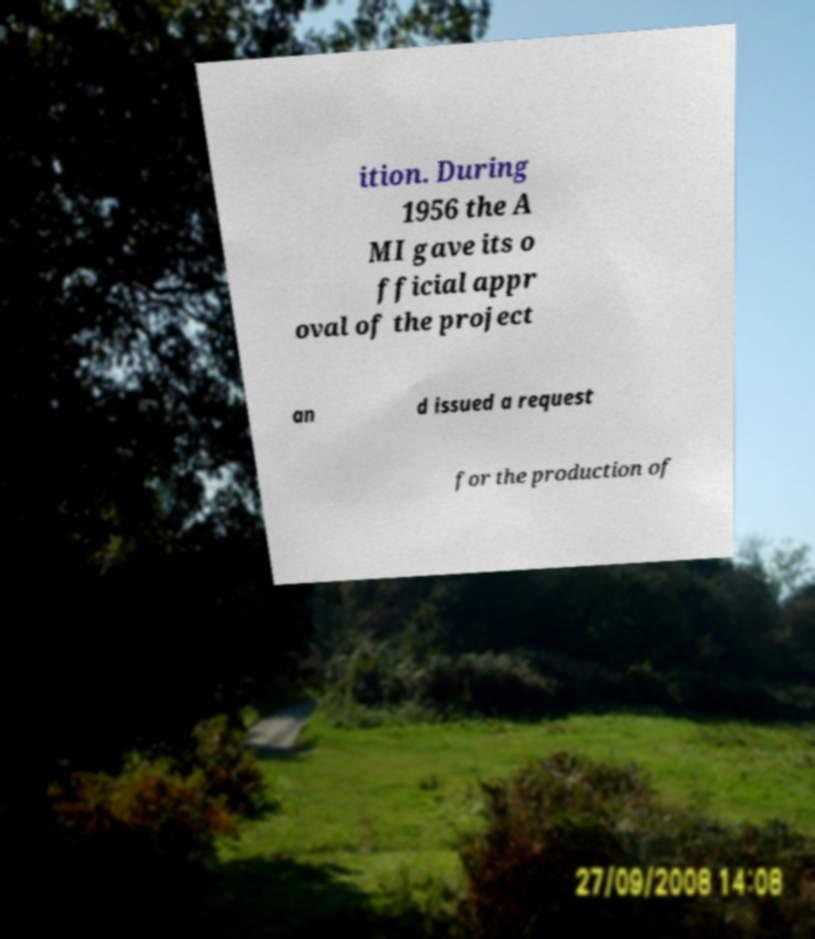Can you accurately transcribe the text from the provided image for me? ition. During 1956 the A MI gave its o fficial appr oval of the project an d issued a request for the production of 